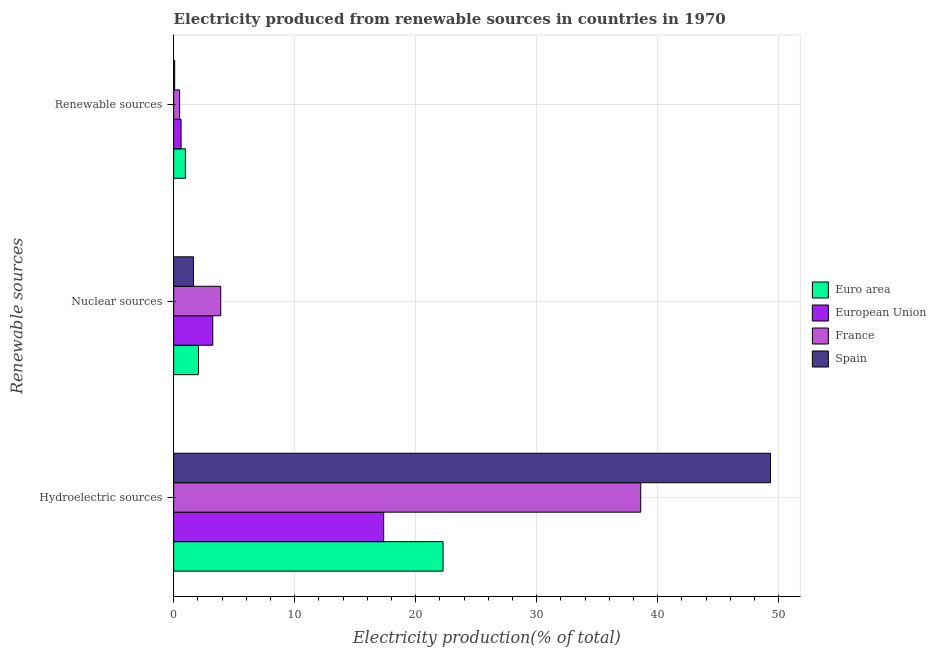How many groups of bars are there?
Keep it short and to the point. 3. Are the number of bars per tick equal to the number of legend labels?
Provide a succinct answer. Yes. Are the number of bars on each tick of the Y-axis equal?
Make the answer very short. Yes. How many bars are there on the 1st tick from the bottom?
Offer a terse response. 4. What is the label of the 2nd group of bars from the top?
Your answer should be compact. Nuclear sources. What is the percentage of electricity produced by hydroelectric sources in Euro area?
Offer a terse response. 22.26. Across all countries, what is the maximum percentage of electricity produced by renewable sources?
Offer a terse response. 0.97. Across all countries, what is the minimum percentage of electricity produced by nuclear sources?
Provide a short and direct response. 1.64. In which country was the percentage of electricity produced by hydroelectric sources maximum?
Provide a short and direct response. Spain. What is the total percentage of electricity produced by hydroelectric sources in the graph?
Your answer should be compact. 127.55. What is the difference between the percentage of electricity produced by nuclear sources in Spain and that in European Union?
Offer a terse response. -1.59. What is the difference between the percentage of electricity produced by renewable sources in Spain and the percentage of electricity produced by hydroelectric sources in France?
Your answer should be very brief. -38.52. What is the average percentage of electricity produced by hydroelectric sources per country?
Keep it short and to the point. 31.89. What is the difference between the percentage of electricity produced by hydroelectric sources and percentage of electricity produced by nuclear sources in Spain?
Your response must be concise. 47.69. What is the ratio of the percentage of electricity produced by hydroelectric sources in France to that in Euro area?
Your answer should be compact. 1.73. Is the percentage of electricity produced by renewable sources in Euro area less than that in Spain?
Provide a short and direct response. No. Is the difference between the percentage of electricity produced by nuclear sources in European Union and Euro area greater than the difference between the percentage of electricity produced by renewable sources in European Union and Euro area?
Keep it short and to the point. Yes. What is the difference between the highest and the second highest percentage of electricity produced by hydroelectric sources?
Provide a short and direct response. 10.73. What is the difference between the highest and the lowest percentage of electricity produced by hydroelectric sources?
Ensure brevity in your answer.  31.97. What does the 2nd bar from the top in Renewable sources represents?
Offer a terse response. France. How many countries are there in the graph?
Provide a succinct answer. 4. What is the difference between two consecutive major ticks on the X-axis?
Provide a succinct answer. 10. Are the values on the major ticks of X-axis written in scientific E-notation?
Your answer should be very brief. No. Does the graph contain any zero values?
Keep it short and to the point. No. Does the graph contain grids?
Provide a succinct answer. Yes. What is the title of the graph?
Make the answer very short. Electricity produced from renewable sources in countries in 1970. What is the label or title of the Y-axis?
Give a very brief answer. Renewable sources. What is the Electricity production(% of total) of Euro area in Hydroelectric sources?
Provide a short and direct response. 22.26. What is the Electricity production(% of total) of European Union in Hydroelectric sources?
Offer a very short reply. 17.36. What is the Electricity production(% of total) of France in Hydroelectric sources?
Offer a very short reply. 38.6. What is the Electricity production(% of total) of Spain in Hydroelectric sources?
Your response must be concise. 49.33. What is the Electricity production(% of total) in Euro area in Nuclear sources?
Keep it short and to the point. 2.05. What is the Electricity production(% of total) of European Union in Nuclear sources?
Your answer should be very brief. 3.23. What is the Electricity production(% of total) in France in Nuclear sources?
Make the answer very short. 3.89. What is the Electricity production(% of total) of Spain in Nuclear sources?
Provide a short and direct response. 1.64. What is the Electricity production(% of total) in Euro area in Renewable sources?
Your answer should be very brief. 0.97. What is the Electricity production(% of total) of European Union in Renewable sources?
Your response must be concise. 0.61. What is the Electricity production(% of total) of France in Renewable sources?
Your answer should be very brief. 0.49. What is the Electricity production(% of total) of Spain in Renewable sources?
Your answer should be very brief. 0.08. Across all Renewable sources, what is the maximum Electricity production(% of total) of Euro area?
Your response must be concise. 22.26. Across all Renewable sources, what is the maximum Electricity production(% of total) in European Union?
Keep it short and to the point. 17.36. Across all Renewable sources, what is the maximum Electricity production(% of total) in France?
Provide a succinct answer. 38.6. Across all Renewable sources, what is the maximum Electricity production(% of total) of Spain?
Ensure brevity in your answer.  49.33. Across all Renewable sources, what is the minimum Electricity production(% of total) of Euro area?
Your answer should be compact. 0.97. Across all Renewable sources, what is the minimum Electricity production(% of total) of European Union?
Provide a succinct answer. 0.61. Across all Renewable sources, what is the minimum Electricity production(% of total) of France?
Your answer should be compact. 0.49. Across all Renewable sources, what is the minimum Electricity production(% of total) of Spain?
Your answer should be compact. 0.08. What is the total Electricity production(% of total) of Euro area in the graph?
Provide a short and direct response. 25.28. What is the total Electricity production(% of total) of European Union in the graph?
Your answer should be very brief. 21.2. What is the total Electricity production(% of total) of France in the graph?
Your response must be concise. 42.98. What is the total Electricity production(% of total) of Spain in the graph?
Provide a succinct answer. 51.05. What is the difference between the Electricity production(% of total) in Euro area in Hydroelectric sources and that in Nuclear sources?
Provide a short and direct response. 20.22. What is the difference between the Electricity production(% of total) in European Union in Hydroelectric sources and that in Nuclear sources?
Keep it short and to the point. 14.12. What is the difference between the Electricity production(% of total) of France in Hydroelectric sources and that in Nuclear sources?
Offer a terse response. 34.71. What is the difference between the Electricity production(% of total) of Spain in Hydroelectric sources and that in Nuclear sources?
Your response must be concise. 47.69. What is the difference between the Electricity production(% of total) of Euro area in Hydroelectric sources and that in Renewable sources?
Your response must be concise. 21.3. What is the difference between the Electricity production(% of total) in European Union in Hydroelectric sources and that in Renewable sources?
Your response must be concise. 16.74. What is the difference between the Electricity production(% of total) of France in Hydroelectric sources and that in Renewable sources?
Provide a succinct answer. 38.11. What is the difference between the Electricity production(% of total) of Spain in Hydroelectric sources and that in Renewable sources?
Provide a succinct answer. 49.24. What is the difference between the Electricity production(% of total) of Euro area in Nuclear sources and that in Renewable sources?
Offer a very short reply. 1.08. What is the difference between the Electricity production(% of total) in European Union in Nuclear sources and that in Renewable sources?
Your response must be concise. 2.62. What is the difference between the Electricity production(% of total) of France in Nuclear sources and that in Renewable sources?
Offer a terse response. 3.4. What is the difference between the Electricity production(% of total) of Spain in Nuclear sources and that in Renewable sources?
Ensure brevity in your answer.  1.56. What is the difference between the Electricity production(% of total) in Euro area in Hydroelectric sources and the Electricity production(% of total) in European Union in Nuclear sources?
Ensure brevity in your answer.  19.03. What is the difference between the Electricity production(% of total) of Euro area in Hydroelectric sources and the Electricity production(% of total) of France in Nuclear sources?
Make the answer very short. 18.37. What is the difference between the Electricity production(% of total) in Euro area in Hydroelectric sources and the Electricity production(% of total) in Spain in Nuclear sources?
Your answer should be compact. 20.63. What is the difference between the Electricity production(% of total) of European Union in Hydroelectric sources and the Electricity production(% of total) of France in Nuclear sources?
Give a very brief answer. 13.47. What is the difference between the Electricity production(% of total) in European Union in Hydroelectric sources and the Electricity production(% of total) in Spain in Nuclear sources?
Offer a very short reply. 15.72. What is the difference between the Electricity production(% of total) of France in Hydroelectric sources and the Electricity production(% of total) of Spain in Nuclear sources?
Offer a very short reply. 36.96. What is the difference between the Electricity production(% of total) in Euro area in Hydroelectric sources and the Electricity production(% of total) in European Union in Renewable sources?
Give a very brief answer. 21.65. What is the difference between the Electricity production(% of total) of Euro area in Hydroelectric sources and the Electricity production(% of total) of France in Renewable sources?
Ensure brevity in your answer.  21.77. What is the difference between the Electricity production(% of total) of Euro area in Hydroelectric sources and the Electricity production(% of total) of Spain in Renewable sources?
Offer a terse response. 22.18. What is the difference between the Electricity production(% of total) in European Union in Hydroelectric sources and the Electricity production(% of total) in France in Renewable sources?
Make the answer very short. 16.86. What is the difference between the Electricity production(% of total) of European Union in Hydroelectric sources and the Electricity production(% of total) of Spain in Renewable sources?
Your response must be concise. 17.27. What is the difference between the Electricity production(% of total) of France in Hydroelectric sources and the Electricity production(% of total) of Spain in Renewable sources?
Ensure brevity in your answer.  38.52. What is the difference between the Electricity production(% of total) in Euro area in Nuclear sources and the Electricity production(% of total) in European Union in Renewable sources?
Your answer should be very brief. 1.44. What is the difference between the Electricity production(% of total) of Euro area in Nuclear sources and the Electricity production(% of total) of France in Renewable sources?
Keep it short and to the point. 1.55. What is the difference between the Electricity production(% of total) of Euro area in Nuclear sources and the Electricity production(% of total) of Spain in Renewable sources?
Make the answer very short. 1.96. What is the difference between the Electricity production(% of total) in European Union in Nuclear sources and the Electricity production(% of total) in France in Renewable sources?
Make the answer very short. 2.74. What is the difference between the Electricity production(% of total) of European Union in Nuclear sources and the Electricity production(% of total) of Spain in Renewable sources?
Offer a very short reply. 3.15. What is the difference between the Electricity production(% of total) of France in Nuclear sources and the Electricity production(% of total) of Spain in Renewable sources?
Keep it short and to the point. 3.81. What is the average Electricity production(% of total) of Euro area per Renewable sources?
Provide a short and direct response. 8.43. What is the average Electricity production(% of total) of European Union per Renewable sources?
Ensure brevity in your answer.  7.07. What is the average Electricity production(% of total) of France per Renewable sources?
Offer a terse response. 14.33. What is the average Electricity production(% of total) in Spain per Renewable sources?
Offer a very short reply. 17.02. What is the difference between the Electricity production(% of total) in Euro area and Electricity production(% of total) in European Union in Hydroelectric sources?
Give a very brief answer. 4.91. What is the difference between the Electricity production(% of total) of Euro area and Electricity production(% of total) of France in Hydroelectric sources?
Your response must be concise. -16.34. What is the difference between the Electricity production(% of total) of Euro area and Electricity production(% of total) of Spain in Hydroelectric sources?
Ensure brevity in your answer.  -27.06. What is the difference between the Electricity production(% of total) in European Union and Electricity production(% of total) in France in Hydroelectric sources?
Provide a short and direct response. -21.24. What is the difference between the Electricity production(% of total) in European Union and Electricity production(% of total) in Spain in Hydroelectric sources?
Give a very brief answer. -31.97. What is the difference between the Electricity production(% of total) of France and Electricity production(% of total) of Spain in Hydroelectric sources?
Provide a short and direct response. -10.73. What is the difference between the Electricity production(% of total) in Euro area and Electricity production(% of total) in European Union in Nuclear sources?
Give a very brief answer. -1.19. What is the difference between the Electricity production(% of total) of Euro area and Electricity production(% of total) of France in Nuclear sources?
Ensure brevity in your answer.  -1.84. What is the difference between the Electricity production(% of total) of Euro area and Electricity production(% of total) of Spain in Nuclear sources?
Provide a short and direct response. 0.41. What is the difference between the Electricity production(% of total) of European Union and Electricity production(% of total) of France in Nuclear sources?
Offer a very short reply. -0.66. What is the difference between the Electricity production(% of total) in European Union and Electricity production(% of total) in Spain in Nuclear sources?
Make the answer very short. 1.59. What is the difference between the Electricity production(% of total) of France and Electricity production(% of total) of Spain in Nuclear sources?
Your response must be concise. 2.25. What is the difference between the Electricity production(% of total) in Euro area and Electricity production(% of total) in European Union in Renewable sources?
Make the answer very short. 0.36. What is the difference between the Electricity production(% of total) in Euro area and Electricity production(% of total) in France in Renewable sources?
Your answer should be compact. 0.48. What is the difference between the Electricity production(% of total) of Euro area and Electricity production(% of total) of Spain in Renewable sources?
Your answer should be compact. 0.88. What is the difference between the Electricity production(% of total) in European Union and Electricity production(% of total) in France in Renewable sources?
Ensure brevity in your answer.  0.12. What is the difference between the Electricity production(% of total) in European Union and Electricity production(% of total) in Spain in Renewable sources?
Provide a short and direct response. 0.53. What is the difference between the Electricity production(% of total) of France and Electricity production(% of total) of Spain in Renewable sources?
Your answer should be compact. 0.41. What is the ratio of the Electricity production(% of total) in Euro area in Hydroelectric sources to that in Nuclear sources?
Your response must be concise. 10.88. What is the ratio of the Electricity production(% of total) in European Union in Hydroelectric sources to that in Nuclear sources?
Provide a succinct answer. 5.37. What is the ratio of the Electricity production(% of total) of France in Hydroelectric sources to that in Nuclear sources?
Offer a terse response. 9.92. What is the ratio of the Electricity production(% of total) of Spain in Hydroelectric sources to that in Nuclear sources?
Your answer should be very brief. 30.09. What is the ratio of the Electricity production(% of total) in Euro area in Hydroelectric sources to that in Renewable sources?
Your answer should be very brief. 23.01. What is the ratio of the Electricity production(% of total) in European Union in Hydroelectric sources to that in Renewable sources?
Your answer should be compact. 28.38. What is the ratio of the Electricity production(% of total) in France in Hydroelectric sources to that in Renewable sources?
Keep it short and to the point. 78.39. What is the ratio of the Electricity production(% of total) in Spain in Hydroelectric sources to that in Renewable sources?
Your answer should be compact. 590.89. What is the ratio of the Electricity production(% of total) of Euro area in Nuclear sources to that in Renewable sources?
Offer a very short reply. 2.12. What is the ratio of the Electricity production(% of total) of European Union in Nuclear sources to that in Renewable sources?
Provide a short and direct response. 5.29. What is the ratio of the Electricity production(% of total) in France in Nuclear sources to that in Renewable sources?
Your response must be concise. 7.9. What is the ratio of the Electricity production(% of total) in Spain in Nuclear sources to that in Renewable sources?
Keep it short and to the point. 19.64. What is the difference between the highest and the second highest Electricity production(% of total) in Euro area?
Provide a succinct answer. 20.22. What is the difference between the highest and the second highest Electricity production(% of total) of European Union?
Your answer should be very brief. 14.12. What is the difference between the highest and the second highest Electricity production(% of total) in France?
Your answer should be compact. 34.71. What is the difference between the highest and the second highest Electricity production(% of total) in Spain?
Offer a very short reply. 47.69. What is the difference between the highest and the lowest Electricity production(% of total) of Euro area?
Provide a short and direct response. 21.3. What is the difference between the highest and the lowest Electricity production(% of total) of European Union?
Ensure brevity in your answer.  16.74. What is the difference between the highest and the lowest Electricity production(% of total) of France?
Provide a succinct answer. 38.11. What is the difference between the highest and the lowest Electricity production(% of total) in Spain?
Provide a short and direct response. 49.24. 